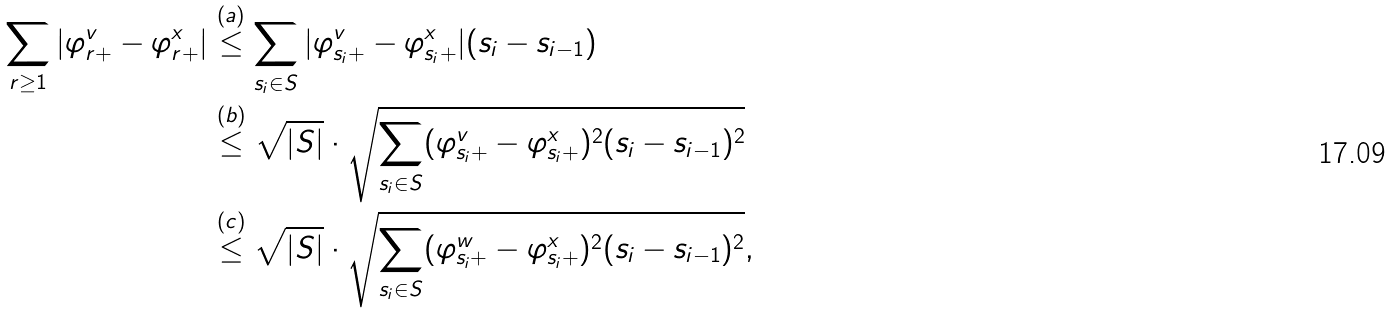<formula> <loc_0><loc_0><loc_500><loc_500>\sum _ { r \geq 1 } | \varphi ^ { v } _ { r + } - \varphi ^ { x } _ { r + } | & \stackrel { ( a ) } { \leq } \sum _ { s _ { i } \in S } | \varphi ^ { v } _ { s _ { i } + } - \varphi ^ { x } _ { s _ { i } + } | ( s _ { i } - s _ { i - 1 } ) \\ & \stackrel { ( b ) } { \leq } \sqrt { | S | } \cdot \sqrt { \sum _ { s _ { i } \in S } ( \varphi ^ { v } _ { s _ { i } + } - \varphi ^ { x } _ { s _ { i } + } ) ^ { 2 } ( s _ { i } - s _ { i - 1 } ) ^ { 2 } } \\ & \stackrel { ( c ) } { \leq } \sqrt { | S | } \cdot \sqrt { \sum _ { s _ { i } \in S } ( \varphi ^ { w } _ { s _ { i } + } - \varphi ^ { x } _ { s _ { i } + } ) ^ { 2 } ( s _ { i } - s _ { i - 1 } ) ^ { 2 } } ,</formula> 